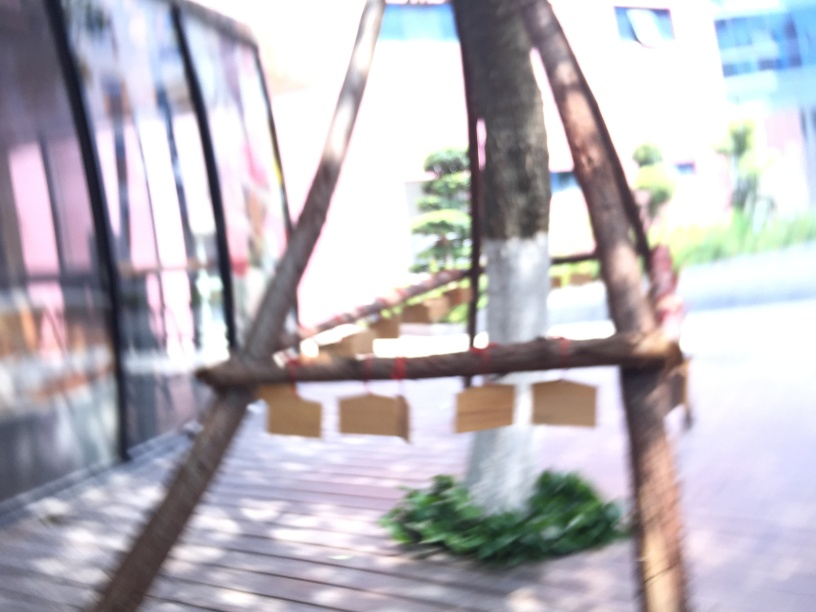Can you describe how the structures in the image might look without overexposure? Without overexposure, the structures in the image, likely a bridge or walkway with handrails and surrounding vegetation, would appear with sharper details. The colors of the metal and wood, as well as the foliage, would be more defined and true to their natural appearance. 